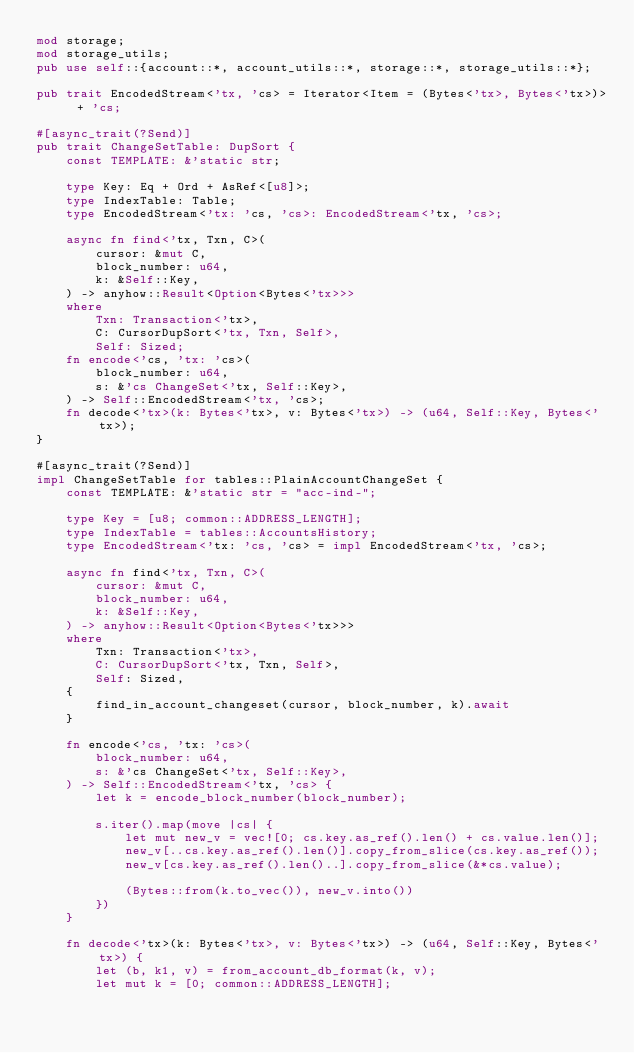Convert code to text. <code><loc_0><loc_0><loc_500><loc_500><_Rust_>mod storage;
mod storage_utils;
pub use self::{account::*, account_utils::*, storage::*, storage_utils::*};

pub trait EncodedStream<'tx, 'cs> = Iterator<Item = (Bytes<'tx>, Bytes<'tx>)> + 'cs;

#[async_trait(?Send)]
pub trait ChangeSetTable: DupSort {
    const TEMPLATE: &'static str;

    type Key: Eq + Ord + AsRef<[u8]>;
    type IndexTable: Table;
    type EncodedStream<'tx: 'cs, 'cs>: EncodedStream<'tx, 'cs>;

    async fn find<'tx, Txn, C>(
        cursor: &mut C,
        block_number: u64,
        k: &Self::Key,
    ) -> anyhow::Result<Option<Bytes<'tx>>>
    where
        Txn: Transaction<'tx>,
        C: CursorDupSort<'tx, Txn, Self>,
        Self: Sized;
    fn encode<'cs, 'tx: 'cs>(
        block_number: u64,
        s: &'cs ChangeSet<'tx, Self::Key>,
    ) -> Self::EncodedStream<'tx, 'cs>;
    fn decode<'tx>(k: Bytes<'tx>, v: Bytes<'tx>) -> (u64, Self::Key, Bytes<'tx>);
}

#[async_trait(?Send)]
impl ChangeSetTable for tables::PlainAccountChangeSet {
    const TEMPLATE: &'static str = "acc-ind-";

    type Key = [u8; common::ADDRESS_LENGTH];
    type IndexTable = tables::AccountsHistory;
    type EncodedStream<'tx: 'cs, 'cs> = impl EncodedStream<'tx, 'cs>;

    async fn find<'tx, Txn, C>(
        cursor: &mut C,
        block_number: u64,
        k: &Self::Key,
    ) -> anyhow::Result<Option<Bytes<'tx>>>
    where
        Txn: Transaction<'tx>,
        C: CursorDupSort<'tx, Txn, Self>,
        Self: Sized,
    {
        find_in_account_changeset(cursor, block_number, k).await
    }

    fn encode<'cs, 'tx: 'cs>(
        block_number: u64,
        s: &'cs ChangeSet<'tx, Self::Key>,
    ) -> Self::EncodedStream<'tx, 'cs> {
        let k = encode_block_number(block_number);

        s.iter().map(move |cs| {
            let mut new_v = vec![0; cs.key.as_ref().len() + cs.value.len()];
            new_v[..cs.key.as_ref().len()].copy_from_slice(cs.key.as_ref());
            new_v[cs.key.as_ref().len()..].copy_from_slice(&*cs.value);

            (Bytes::from(k.to_vec()), new_v.into())
        })
    }

    fn decode<'tx>(k: Bytes<'tx>, v: Bytes<'tx>) -> (u64, Self::Key, Bytes<'tx>) {
        let (b, k1, v) = from_account_db_format(k, v);
        let mut k = [0; common::ADDRESS_LENGTH];</code> 